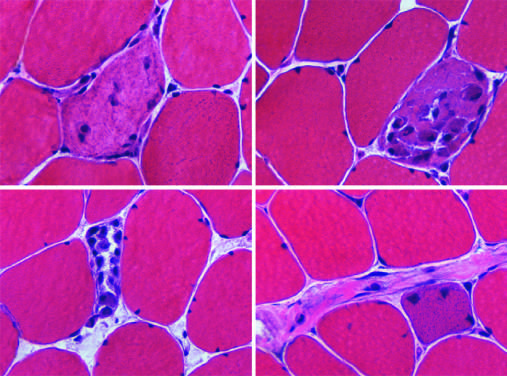re regenerative myofibers characterized by cytoplasmic basophilia and enlarged nucleoli not visible at this power?
Answer the question using a single word or phrase. Yes 